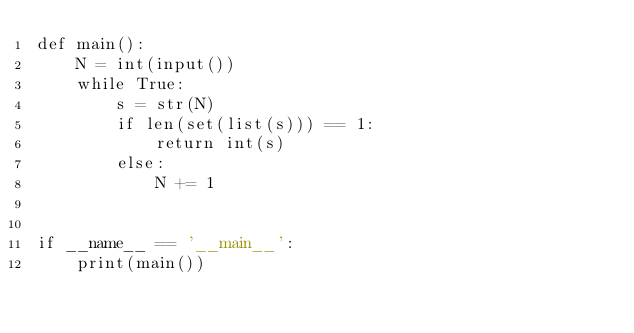Convert code to text. <code><loc_0><loc_0><loc_500><loc_500><_Python_>def main():
    N = int(input())
    while True:
        s = str(N)
        if len(set(list(s))) == 1:
            return int(s)
        else:
            N += 1
    

if __name__ == '__main__':
    print(main())</code> 